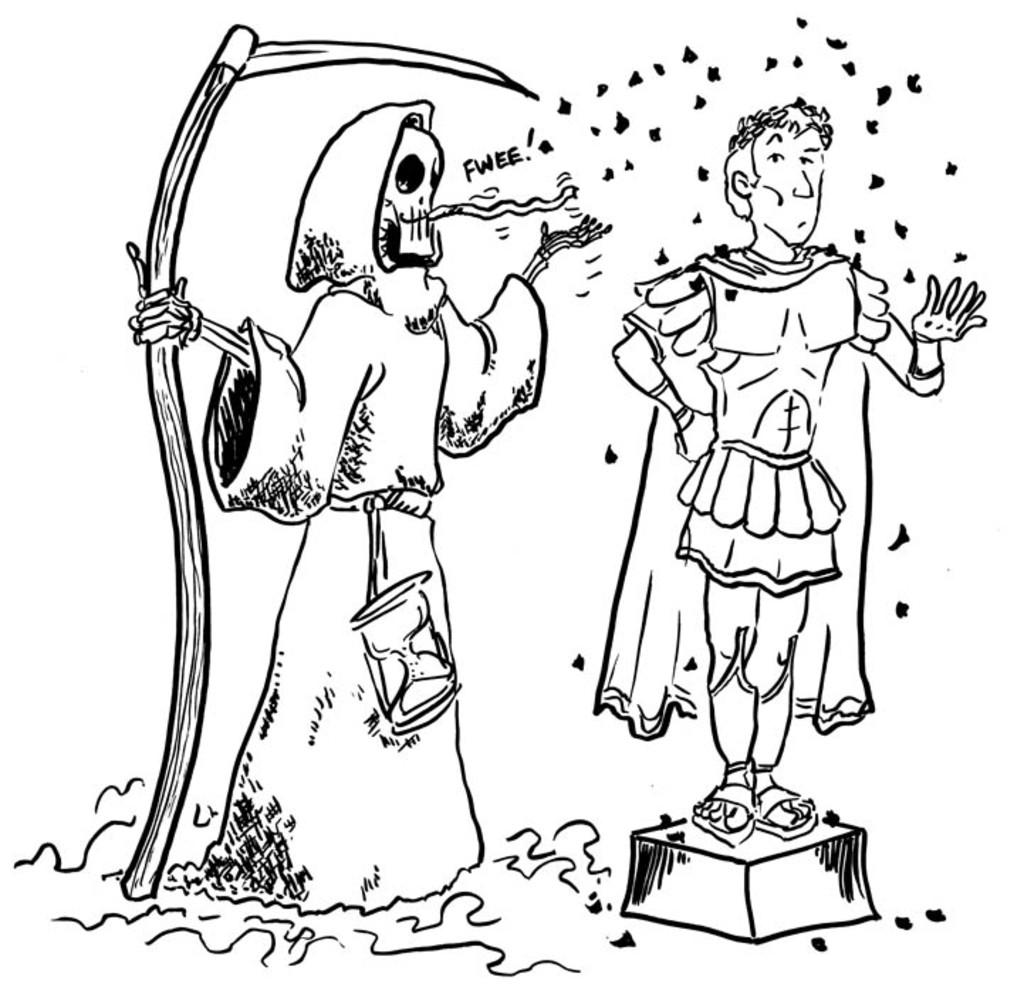How many people are in the image? There are two persons in the image. What are the persons doing in the image? The persons are standing. What type of surface is visible at the bottom of the image? There is grass at the bottom of the image. What type of nut can be seen growing on the grass in the image? There are no nuts visible in the image, and the grass is not the type of surface where nuts typically grow. 